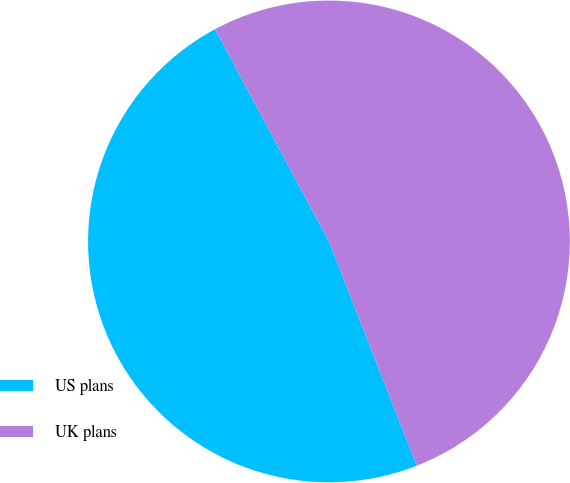Convert chart. <chart><loc_0><loc_0><loc_500><loc_500><pie_chart><fcel>US plans<fcel>UK plans<nl><fcel>48.1%<fcel>51.9%<nl></chart> 